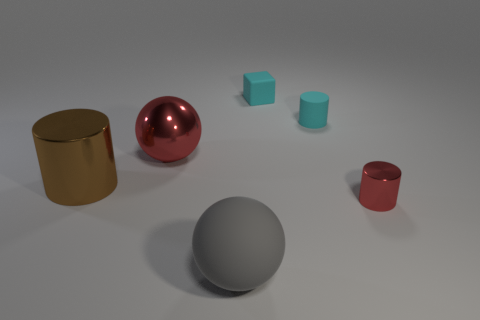Add 3 cyan rubber things. How many objects exist? 9 Subtract all spheres. How many objects are left? 4 Subtract 1 cyan cylinders. How many objects are left? 5 Subtract all balls. Subtract all big red objects. How many objects are left? 3 Add 3 big shiny cylinders. How many big shiny cylinders are left? 4 Add 4 small red objects. How many small red objects exist? 5 